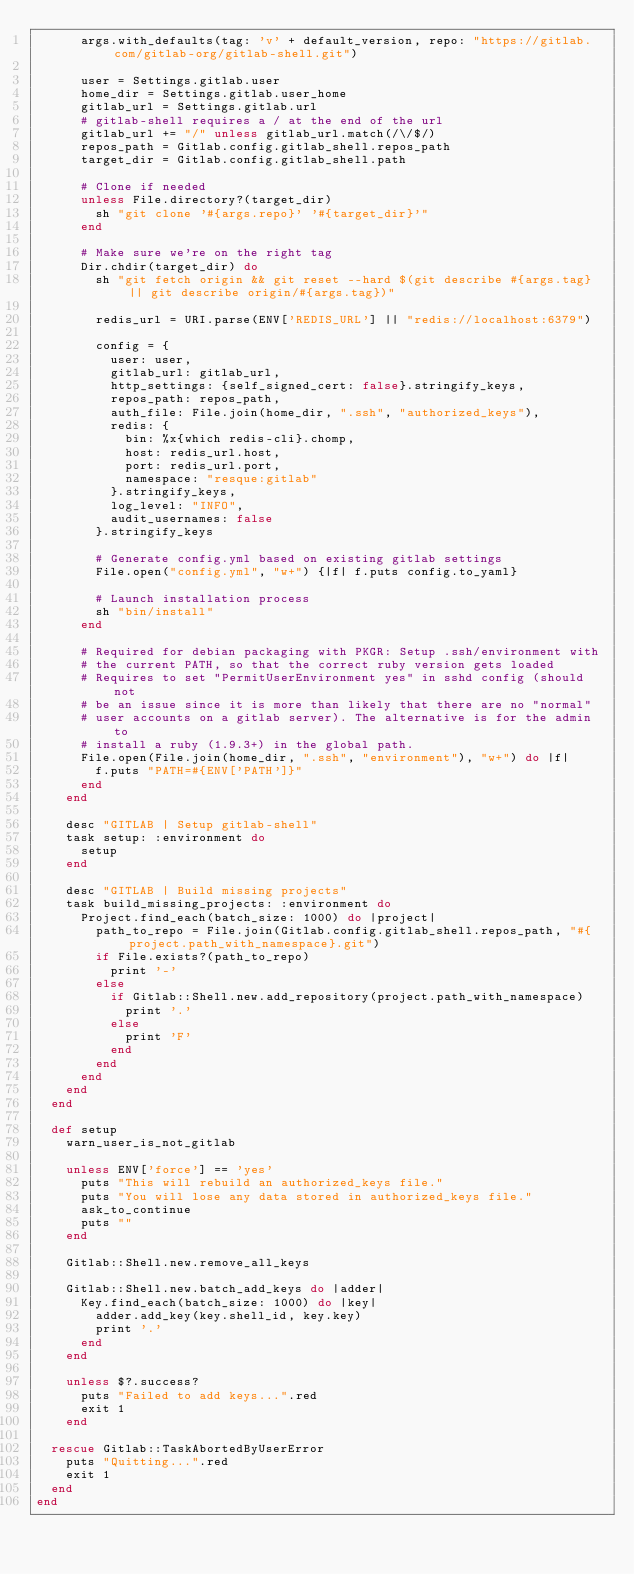Convert code to text. <code><loc_0><loc_0><loc_500><loc_500><_Ruby_>      args.with_defaults(tag: 'v' + default_version, repo: "https://gitlab.com/gitlab-org/gitlab-shell.git")

      user = Settings.gitlab.user
      home_dir = Settings.gitlab.user_home
      gitlab_url = Settings.gitlab.url
      # gitlab-shell requires a / at the end of the url
      gitlab_url += "/" unless gitlab_url.match(/\/$/)
      repos_path = Gitlab.config.gitlab_shell.repos_path
      target_dir = Gitlab.config.gitlab_shell.path

      # Clone if needed
      unless File.directory?(target_dir)
        sh "git clone '#{args.repo}' '#{target_dir}'"
      end

      # Make sure we're on the right tag
      Dir.chdir(target_dir) do
        sh "git fetch origin && git reset --hard $(git describe #{args.tag} || git describe origin/#{args.tag})"

        redis_url = URI.parse(ENV['REDIS_URL'] || "redis://localhost:6379")

        config = {
          user: user,
          gitlab_url: gitlab_url,
          http_settings: {self_signed_cert: false}.stringify_keys,
          repos_path: repos_path,
          auth_file: File.join(home_dir, ".ssh", "authorized_keys"),
          redis: {
            bin: %x{which redis-cli}.chomp,
            host: redis_url.host,
            port: redis_url.port,
            namespace: "resque:gitlab"
          }.stringify_keys,
          log_level: "INFO",
          audit_usernames: false
        }.stringify_keys

        # Generate config.yml based on existing gitlab settings
        File.open("config.yml", "w+") {|f| f.puts config.to_yaml}

        # Launch installation process
        sh "bin/install"
      end

      # Required for debian packaging with PKGR: Setup .ssh/environment with
      # the current PATH, so that the correct ruby version gets loaded
      # Requires to set "PermitUserEnvironment yes" in sshd config (should not
      # be an issue since it is more than likely that there are no "normal"
      # user accounts on a gitlab server). The alternative is for the admin to
      # install a ruby (1.9.3+) in the global path.
      File.open(File.join(home_dir, ".ssh", "environment"), "w+") do |f|
        f.puts "PATH=#{ENV['PATH']}"
      end
    end

    desc "GITLAB | Setup gitlab-shell"
    task setup: :environment do
      setup
    end

    desc "GITLAB | Build missing projects"
    task build_missing_projects: :environment do
      Project.find_each(batch_size: 1000) do |project|
        path_to_repo = File.join(Gitlab.config.gitlab_shell.repos_path, "#{project.path_with_namespace}.git")
        if File.exists?(path_to_repo)
          print '-'
        else
          if Gitlab::Shell.new.add_repository(project.path_with_namespace)
            print '.'
          else
            print 'F'
          end
        end
      end
    end
  end

  def setup
    warn_user_is_not_gitlab

    unless ENV['force'] == 'yes'
      puts "This will rebuild an authorized_keys file."
      puts "You will lose any data stored in authorized_keys file."
      ask_to_continue
      puts ""
    end

    Gitlab::Shell.new.remove_all_keys

    Gitlab::Shell.new.batch_add_keys do |adder|
      Key.find_each(batch_size: 1000) do |key|
        adder.add_key(key.shell_id, key.key)
        print '.'
      end
    end

    unless $?.success?
      puts "Failed to add keys...".red
      exit 1
    end

  rescue Gitlab::TaskAbortedByUserError
    puts "Quitting...".red
    exit 1
  end
end

</code> 